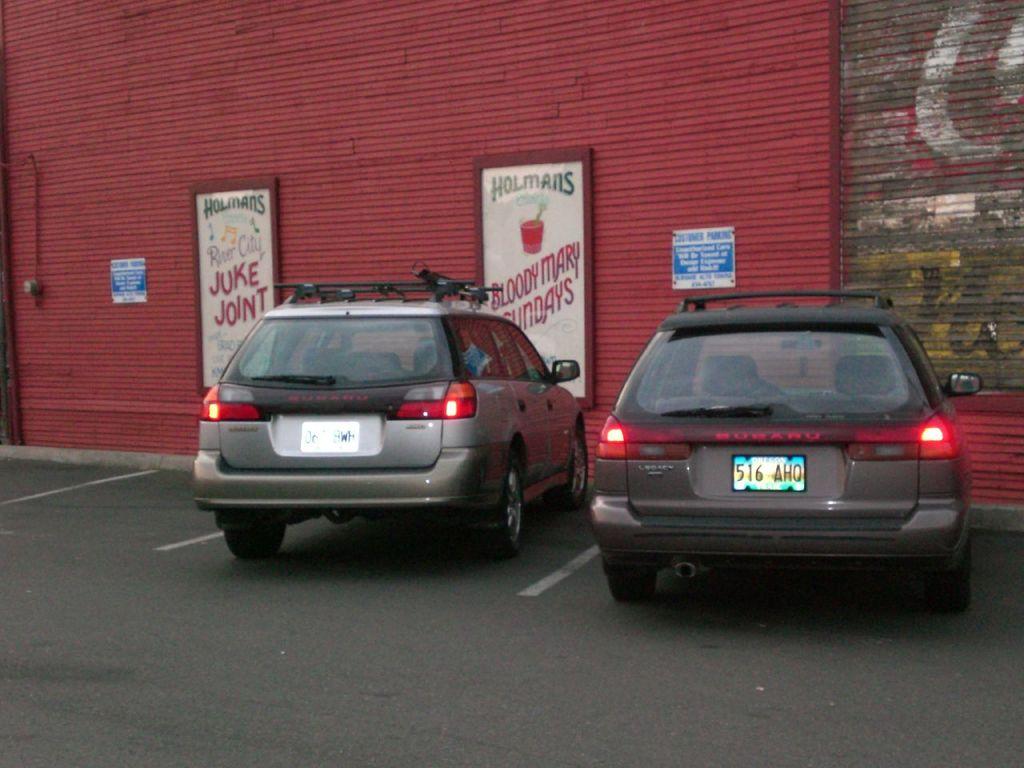What is on the signs?
Your answer should be very brief. Holmans ads. What are the 3 numbers on the plate of the car on the right?
Your answer should be very brief. 516. 